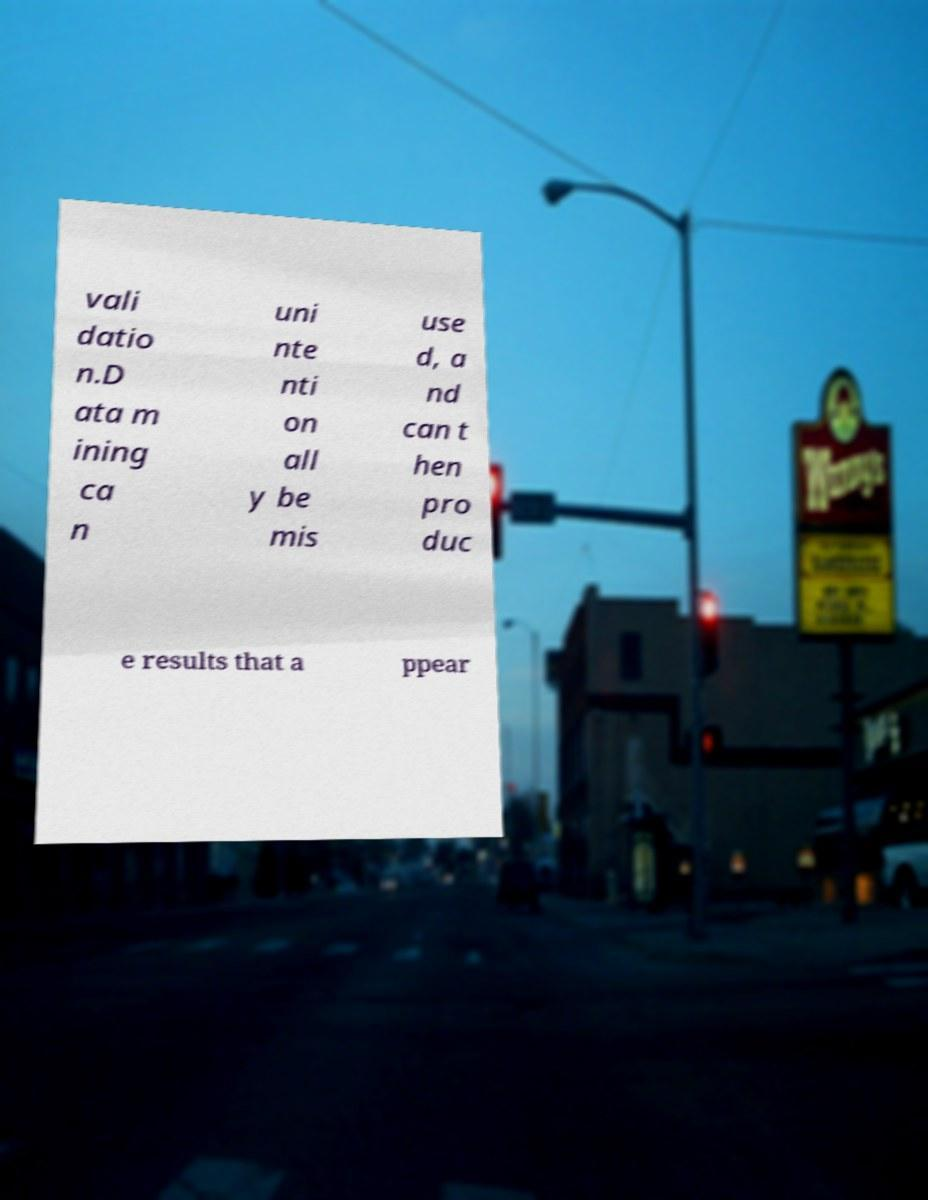Can you read and provide the text displayed in the image?This photo seems to have some interesting text. Can you extract and type it out for me? vali datio n.D ata m ining ca n uni nte nti on all y be mis use d, a nd can t hen pro duc e results that a ppear 